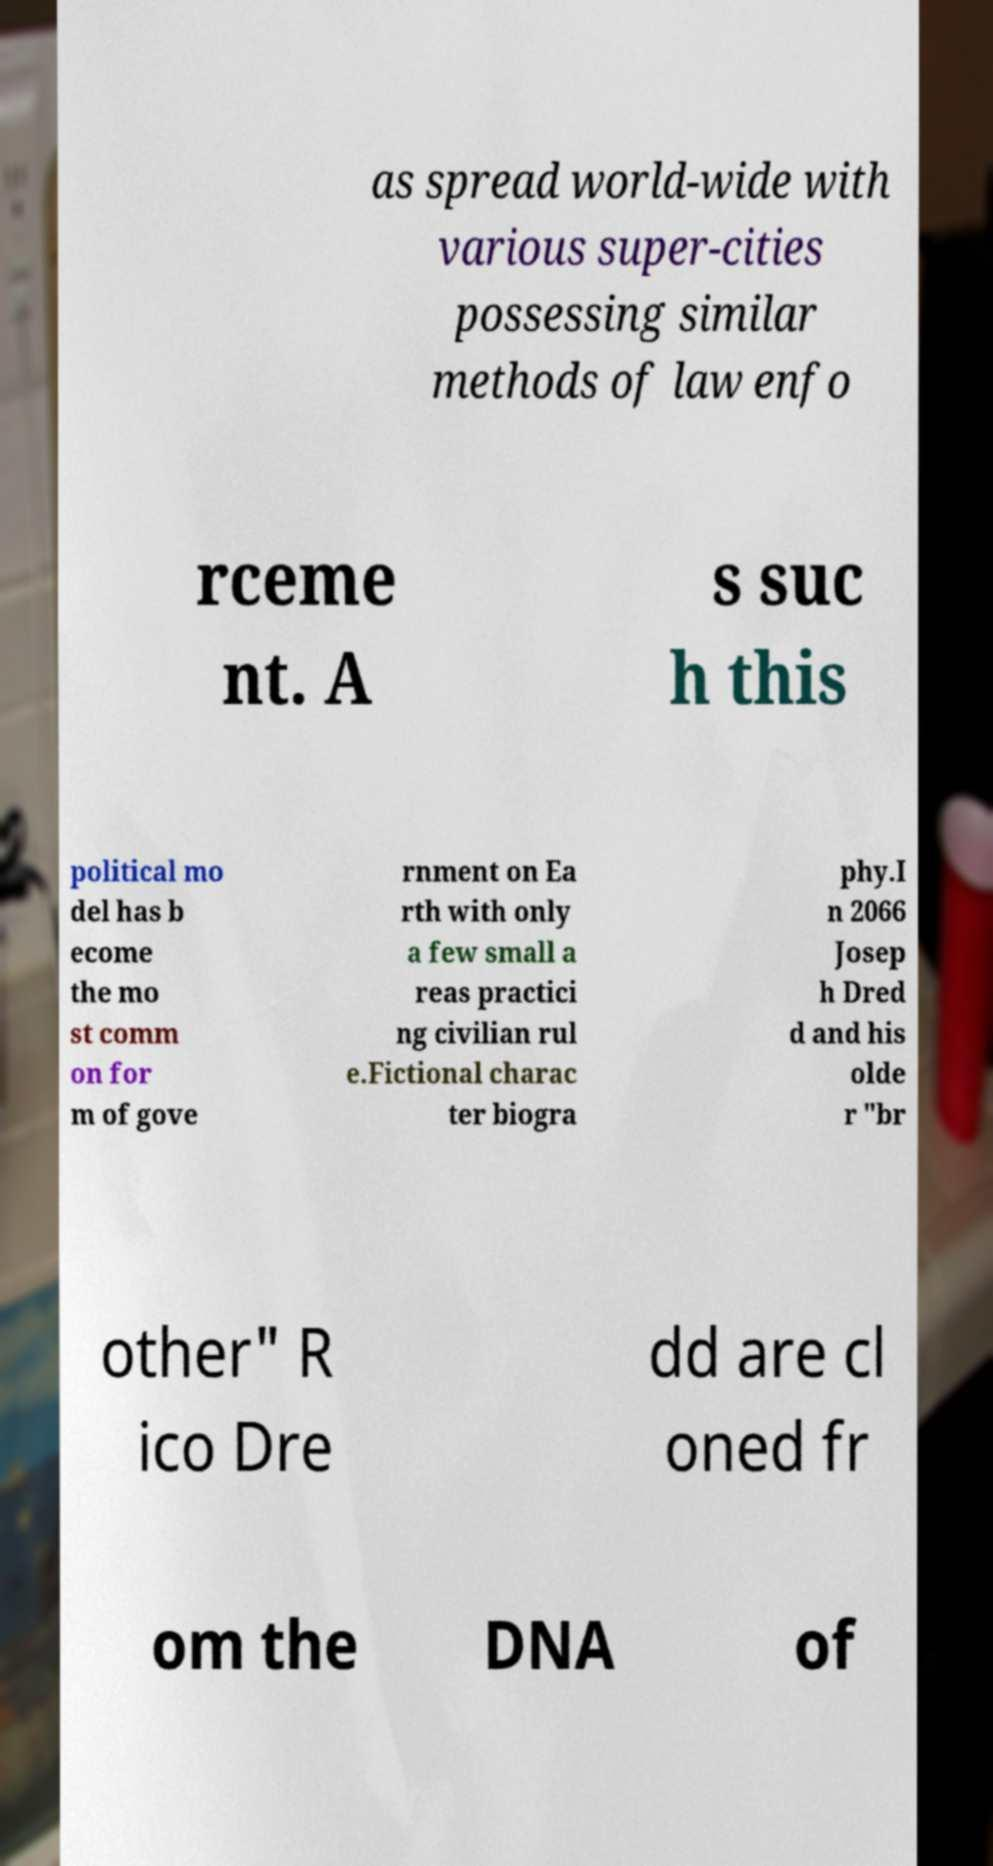There's text embedded in this image that I need extracted. Can you transcribe it verbatim? as spread world-wide with various super-cities possessing similar methods of law enfo rceme nt. A s suc h this political mo del has b ecome the mo st comm on for m of gove rnment on Ea rth with only a few small a reas practici ng civilian rul e.Fictional charac ter biogra phy.I n 2066 Josep h Dred d and his olde r "br other" R ico Dre dd are cl oned fr om the DNA of 